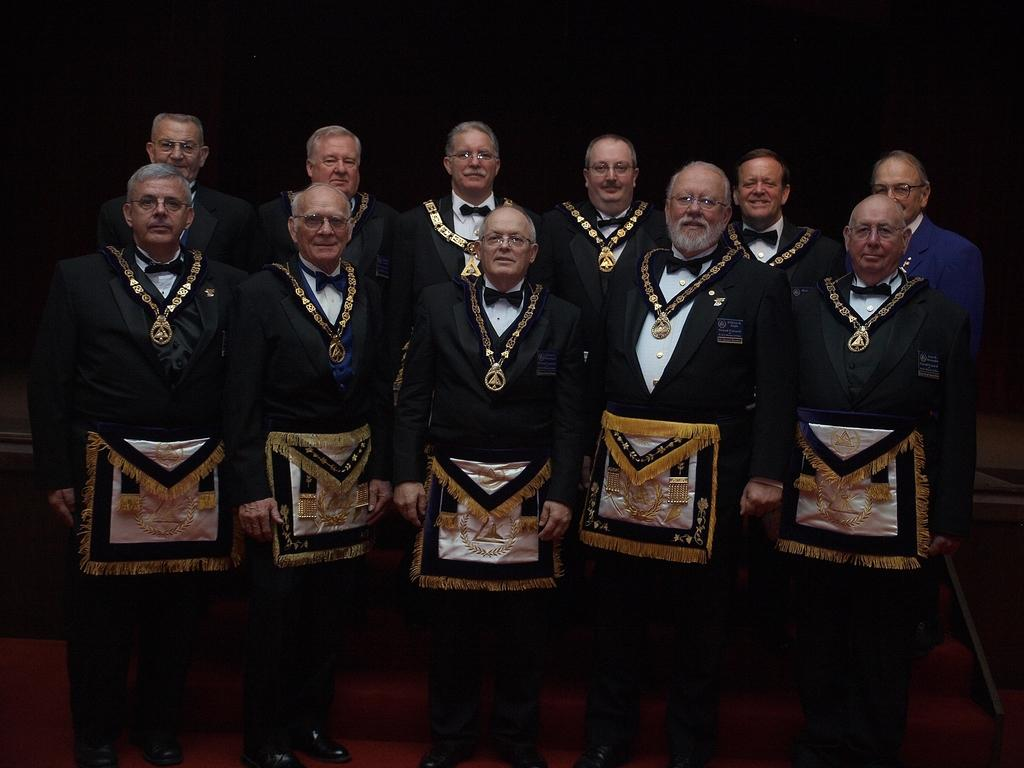What is happening in the image? There are people standing in the image. Can you describe the background of the image? The background of the image is dark. What type of brush is being used to paint the kettle in the image? There is no brush or kettle present in the image; it only features people standing with a dark background. 